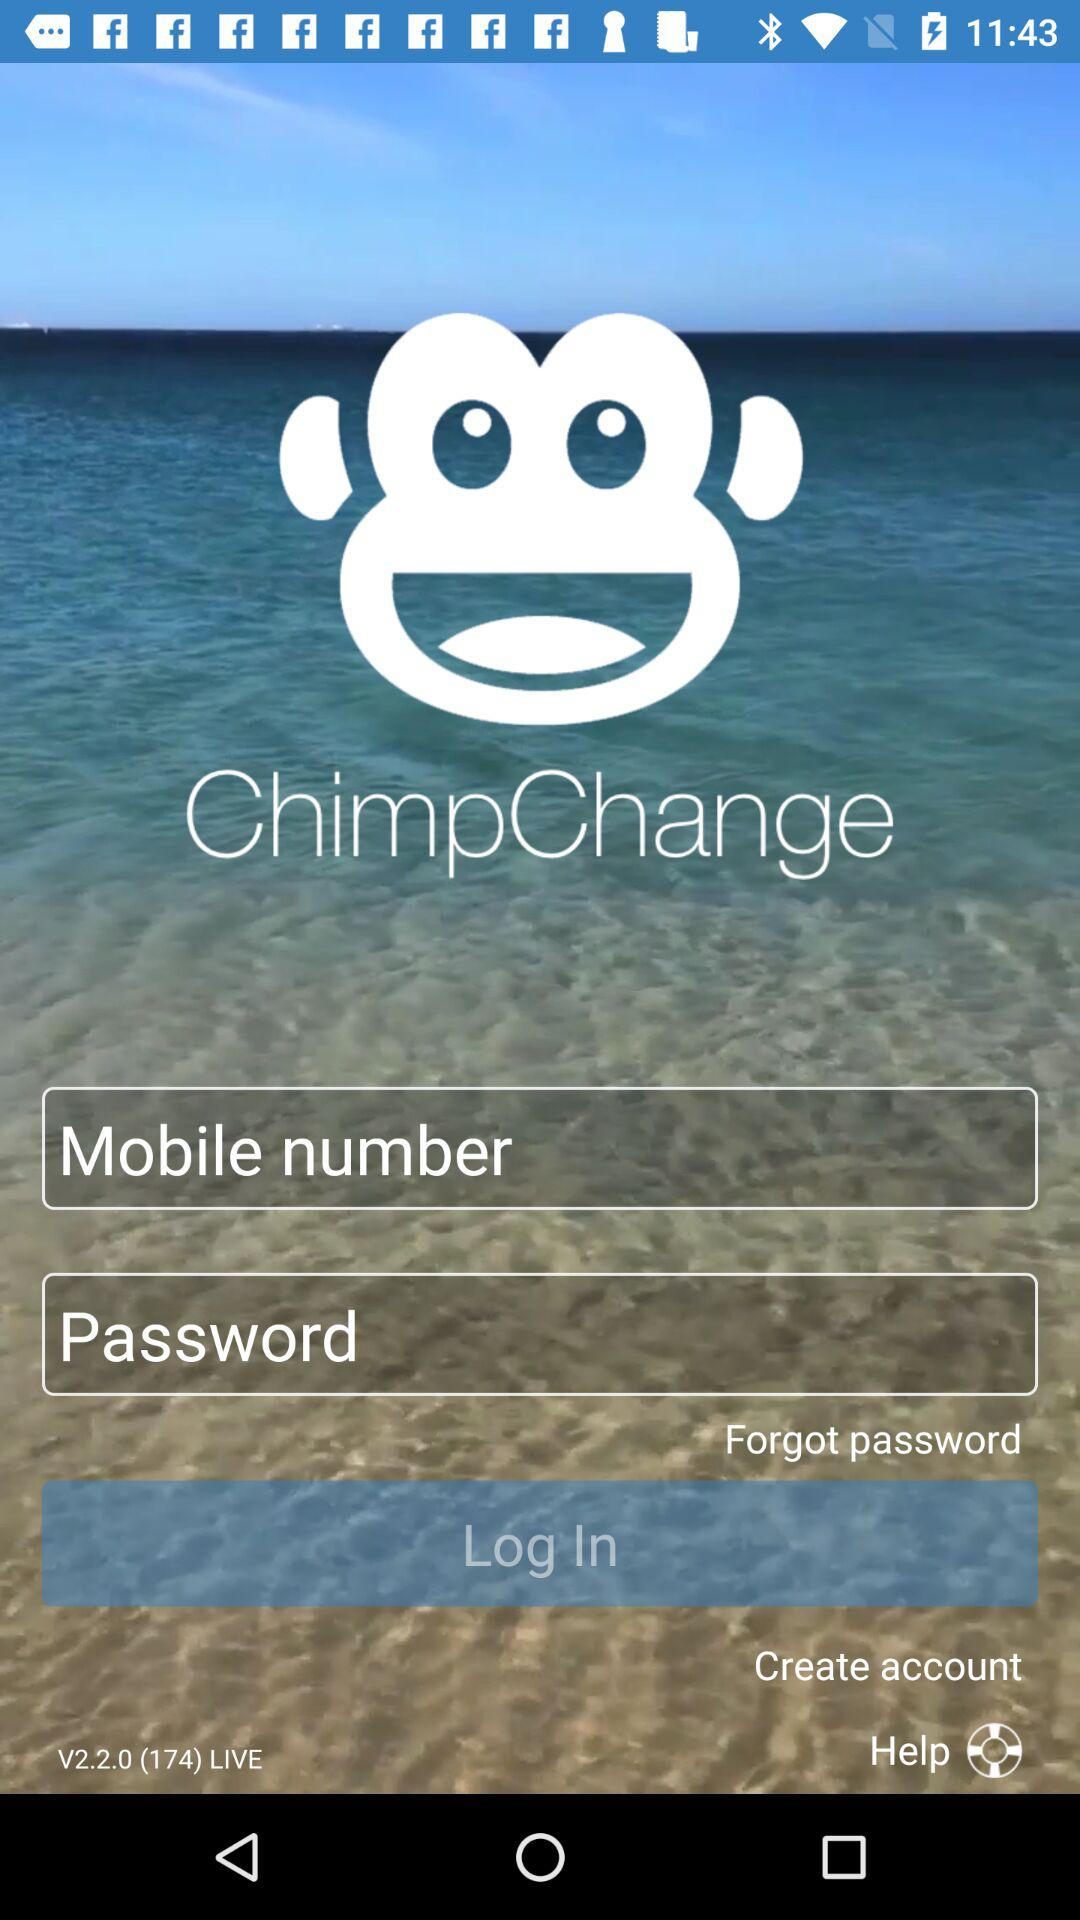What is the name of the application? The name of the application is "ChimpChange". 